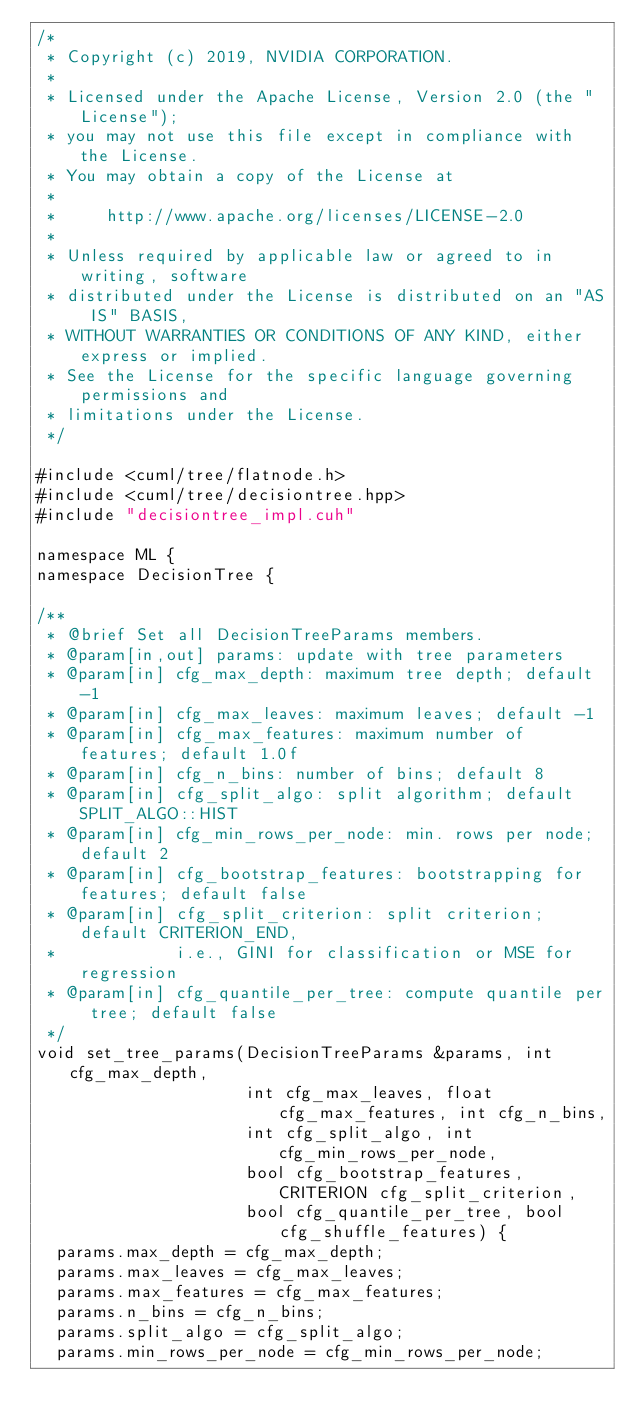<code> <loc_0><loc_0><loc_500><loc_500><_Cuda_>/*
 * Copyright (c) 2019, NVIDIA CORPORATION.
 *
 * Licensed under the Apache License, Version 2.0 (the "License");
 * you may not use this file except in compliance with the License.
 * You may obtain a copy of the License at
 *
 *     http://www.apache.org/licenses/LICENSE-2.0
 *
 * Unless required by applicable law or agreed to in writing, software
 * distributed under the License is distributed on an "AS IS" BASIS,
 * WITHOUT WARRANTIES OR CONDITIONS OF ANY KIND, either express or implied.
 * See the License for the specific language governing permissions and
 * limitations under the License.
 */

#include <cuml/tree/flatnode.h>
#include <cuml/tree/decisiontree.hpp>
#include "decisiontree_impl.cuh"

namespace ML {
namespace DecisionTree {

/**
 * @brief Set all DecisionTreeParams members.
 * @param[in,out] params: update with tree parameters
 * @param[in] cfg_max_depth: maximum tree depth; default -1
 * @param[in] cfg_max_leaves: maximum leaves; default -1
 * @param[in] cfg_max_features: maximum number of features; default 1.0f
 * @param[in] cfg_n_bins: number of bins; default 8
 * @param[in] cfg_split_algo: split algorithm; default SPLIT_ALGO::HIST
 * @param[in] cfg_min_rows_per_node: min. rows per node; default 2
 * @param[in] cfg_bootstrap_features: bootstrapping for features; default false
 * @param[in] cfg_split_criterion: split criterion; default CRITERION_END,
 *            i.e., GINI for classification or MSE for regression
 * @param[in] cfg_quantile_per_tree: compute quantile per tree; default false
 */
void set_tree_params(DecisionTreeParams &params, int cfg_max_depth,
                     int cfg_max_leaves, float cfg_max_features, int cfg_n_bins,
                     int cfg_split_algo, int cfg_min_rows_per_node,
                     bool cfg_bootstrap_features, CRITERION cfg_split_criterion,
                     bool cfg_quantile_per_tree, bool cfg_shuffle_features) {
  params.max_depth = cfg_max_depth;
  params.max_leaves = cfg_max_leaves;
  params.max_features = cfg_max_features;
  params.n_bins = cfg_n_bins;
  params.split_algo = cfg_split_algo;
  params.min_rows_per_node = cfg_min_rows_per_node;</code> 